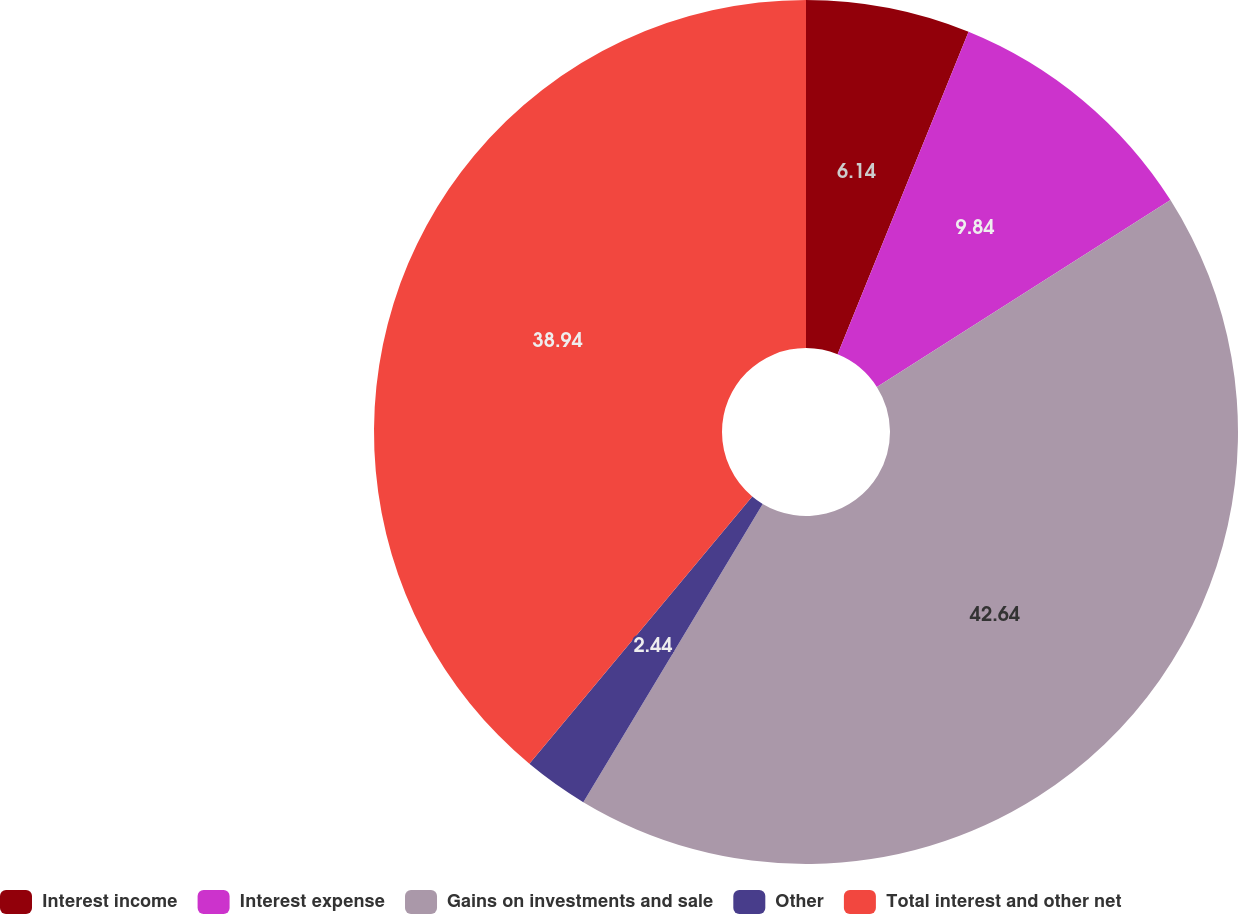Convert chart. <chart><loc_0><loc_0><loc_500><loc_500><pie_chart><fcel>Interest income<fcel>Interest expense<fcel>Gains on investments and sale<fcel>Other<fcel>Total interest and other net<nl><fcel>6.14%<fcel>9.84%<fcel>42.64%<fcel>2.44%<fcel>38.94%<nl></chart> 